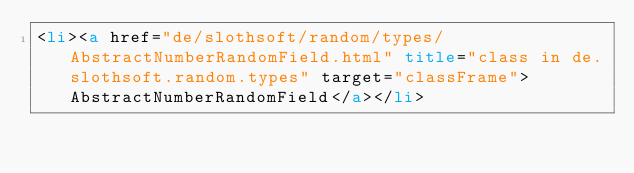<code> <loc_0><loc_0><loc_500><loc_500><_HTML_><li><a href="de/slothsoft/random/types/AbstractNumberRandomField.html" title="class in de.slothsoft.random.types" target="classFrame">AbstractNumberRandomField</a></li></code> 